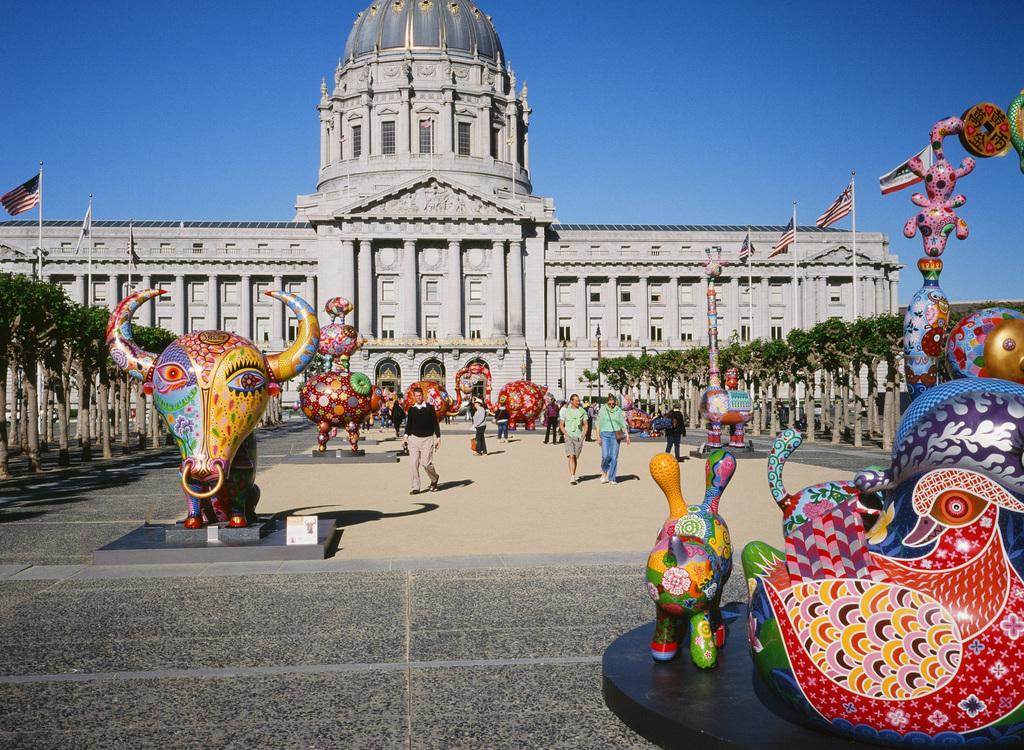What is the main subject in the center of the image? There are statues in the center of the image. What can be observed about the people in the image? There are people with different costumes in the image. What is visible in the background of the image? There is a sky, trees, flags, and a building visible in the background of the image. What advice does the creator of the statues give in the image? There is no indication in the image that the creator of the statues is present or giving advice. 